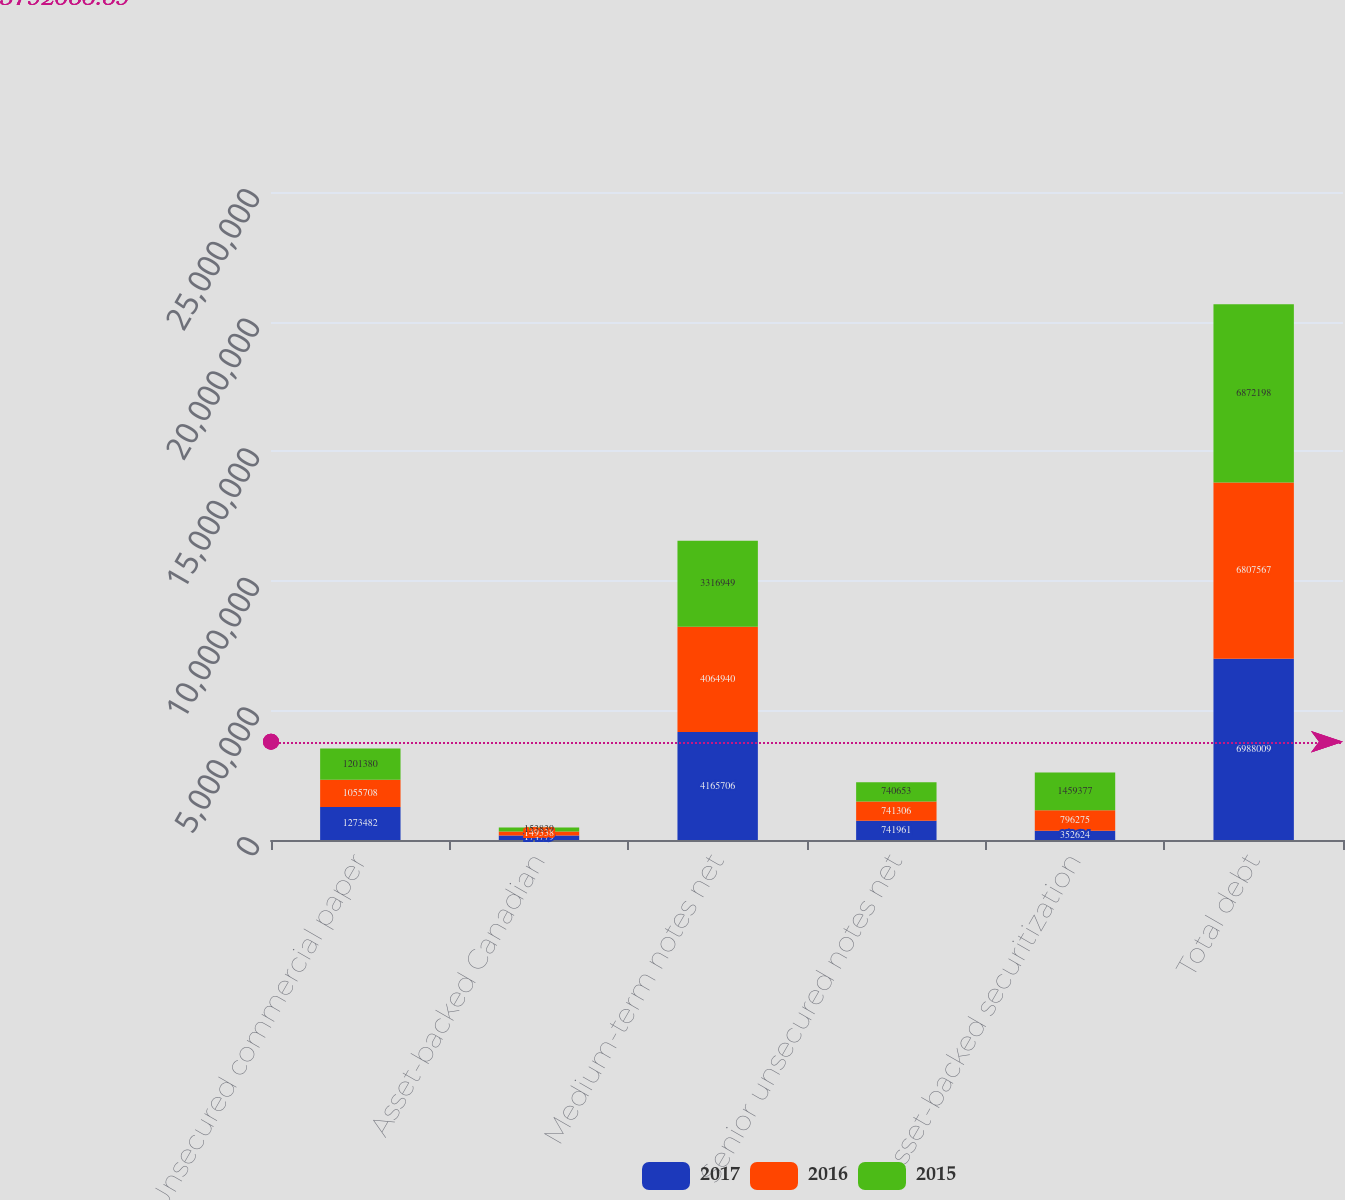Convert chart. <chart><loc_0><loc_0><loc_500><loc_500><stacked_bar_chart><ecel><fcel>Unsecured commercial paper<fcel>Asset-backed Canadian<fcel>Medium-term notes net<fcel>Senior unsecured notes net<fcel>Asset-backed securitization<fcel>Total debt<nl><fcel>2017<fcel>1.27348e+06<fcel>174779<fcel>4.16571e+06<fcel>741961<fcel>352624<fcel>6.98801e+06<nl><fcel>2016<fcel>1.05571e+06<fcel>149338<fcel>4.06494e+06<fcel>741306<fcel>796275<fcel>6.80757e+06<nl><fcel>2015<fcel>1.20138e+06<fcel>153839<fcel>3.31695e+06<fcel>740653<fcel>1.45938e+06<fcel>6.8722e+06<nl></chart> 